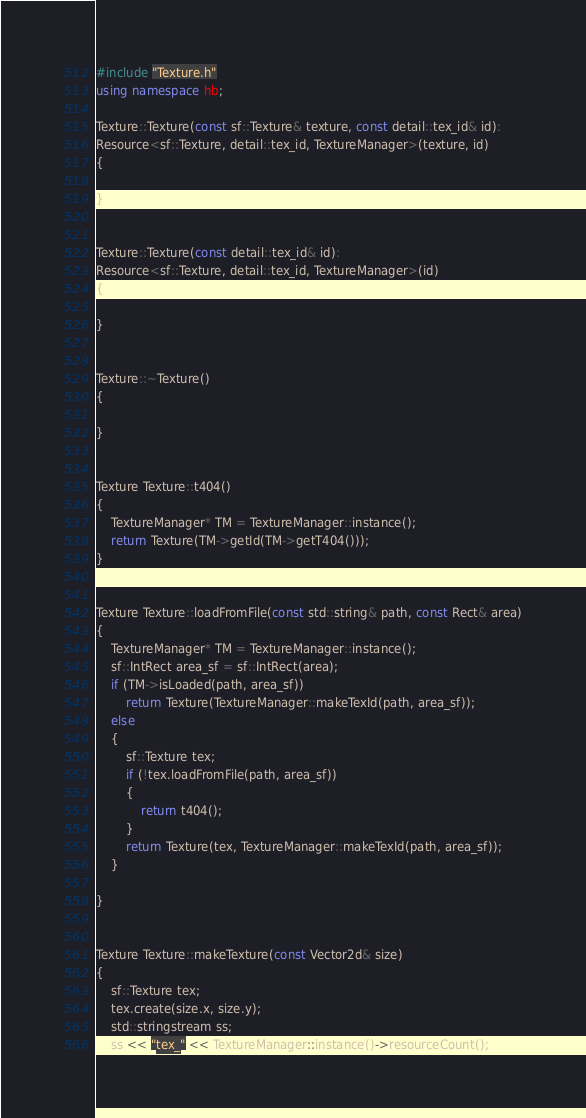Convert code to text. <code><loc_0><loc_0><loc_500><loc_500><_C++_>#include "Texture.h"
using namespace hb;

Texture::Texture(const sf::Texture& texture, const detail::tex_id& id):
Resource<sf::Texture, detail::tex_id, TextureManager>(texture, id)
{

}


Texture::Texture(const detail::tex_id& id):
Resource<sf::Texture, detail::tex_id, TextureManager>(id)
{

}


Texture::~Texture()
{

}


Texture Texture::t404()
{
	TextureManager* TM = TextureManager::instance();
	return Texture(TM->getId(TM->getT404()));
}


Texture Texture::loadFromFile(const std::string& path, const Rect& area)
{
	TextureManager* TM = TextureManager::instance();
	sf::IntRect area_sf = sf::IntRect(area);
	if (TM->isLoaded(path, area_sf))
		return Texture(TextureManager::makeTexId(path, area_sf));
	else
	{
		sf::Texture tex;
		if (!tex.loadFromFile(path, area_sf))
		{
			return t404();
		}
		return Texture(tex, TextureManager::makeTexId(path, area_sf));
	}

}


Texture Texture::makeTexture(const Vector2d& size)
{
	sf::Texture tex;
	tex.create(size.x, size.y);
	std::stringstream ss;
	ss << "tex_" << TextureManager::instance()->resourceCount();</code> 